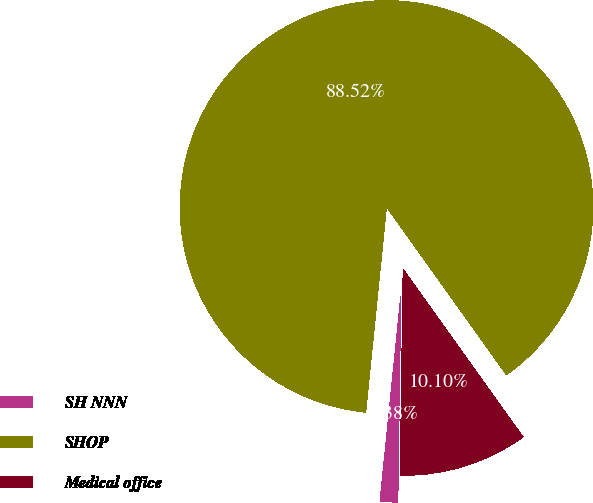Convert chart to OTSL. <chart><loc_0><loc_0><loc_500><loc_500><pie_chart><fcel>SH NNN<fcel>SHOP<fcel>Medical office<nl><fcel>1.38%<fcel>88.52%<fcel>10.1%<nl></chart> 